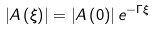Convert formula to latex. <formula><loc_0><loc_0><loc_500><loc_500>\left | A \left ( \xi \right ) \right | = \left | A \left ( 0 \right ) \right | e ^ { - \Gamma \xi }</formula> 